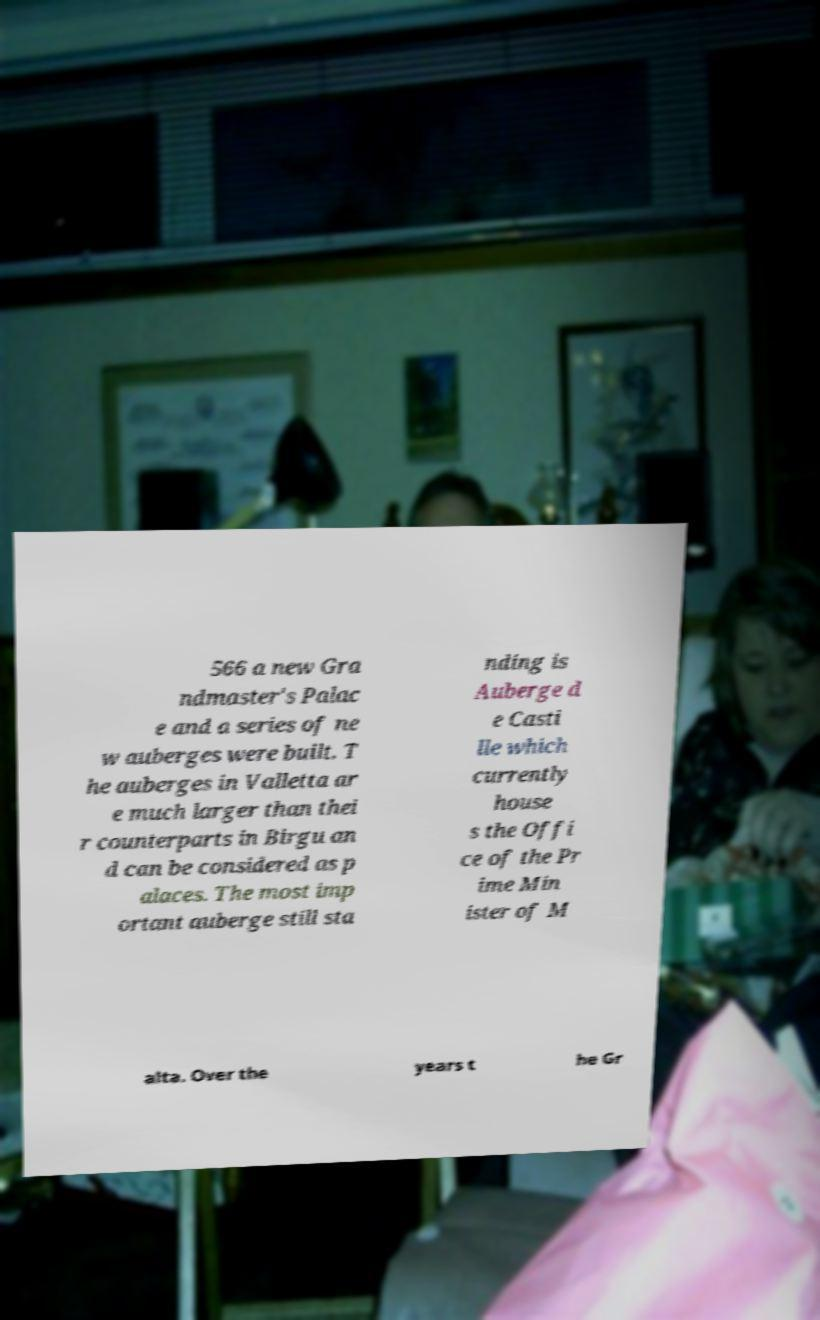Could you extract and type out the text from this image? 566 a new Gra ndmaster's Palac e and a series of ne w auberges were built. T he auberges in Valletta ar e much larger than thei r counterparts in Birgu an d can be considered as p alaces. The most imp ortant auberge still sta nding is Auberge d e Casti lle which currently house s the Offi ce of the Pr ime Min ister of M alta. Over the years t he Gr 